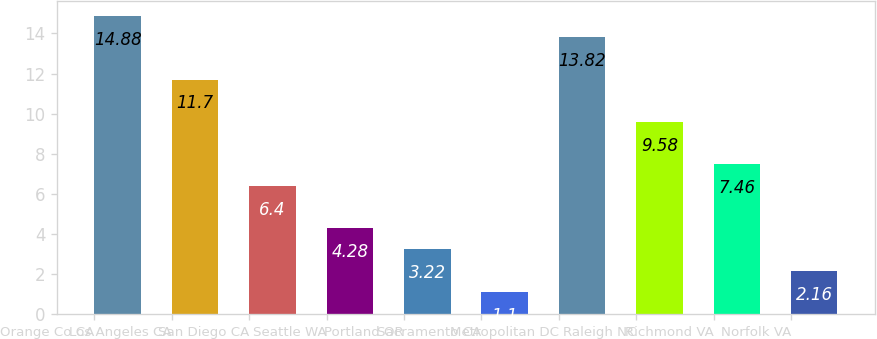Convert chart. <chart><loc_0><loc_0><loc_500><loc_500><bar_chart><fcel>Orange Co CA<fcel>Los Angeles CA<fcel>San Diego CA<fcel>Seattle WA<fcel>Portland OR<fcel>Sacramento CA<fcel>Metropolitan DC<fcel>Raleigh NC<fcel>Richmond VA<fcel>Norfolk VA<nl><fcel>14.88<fcel>11.7<fcel>6.4<fcel>4.28<fcel>3.22<fcel>1.1<fcel>13.82<fcel>9.58<fcel>7.46<fcel>2.16<nl></chart> 